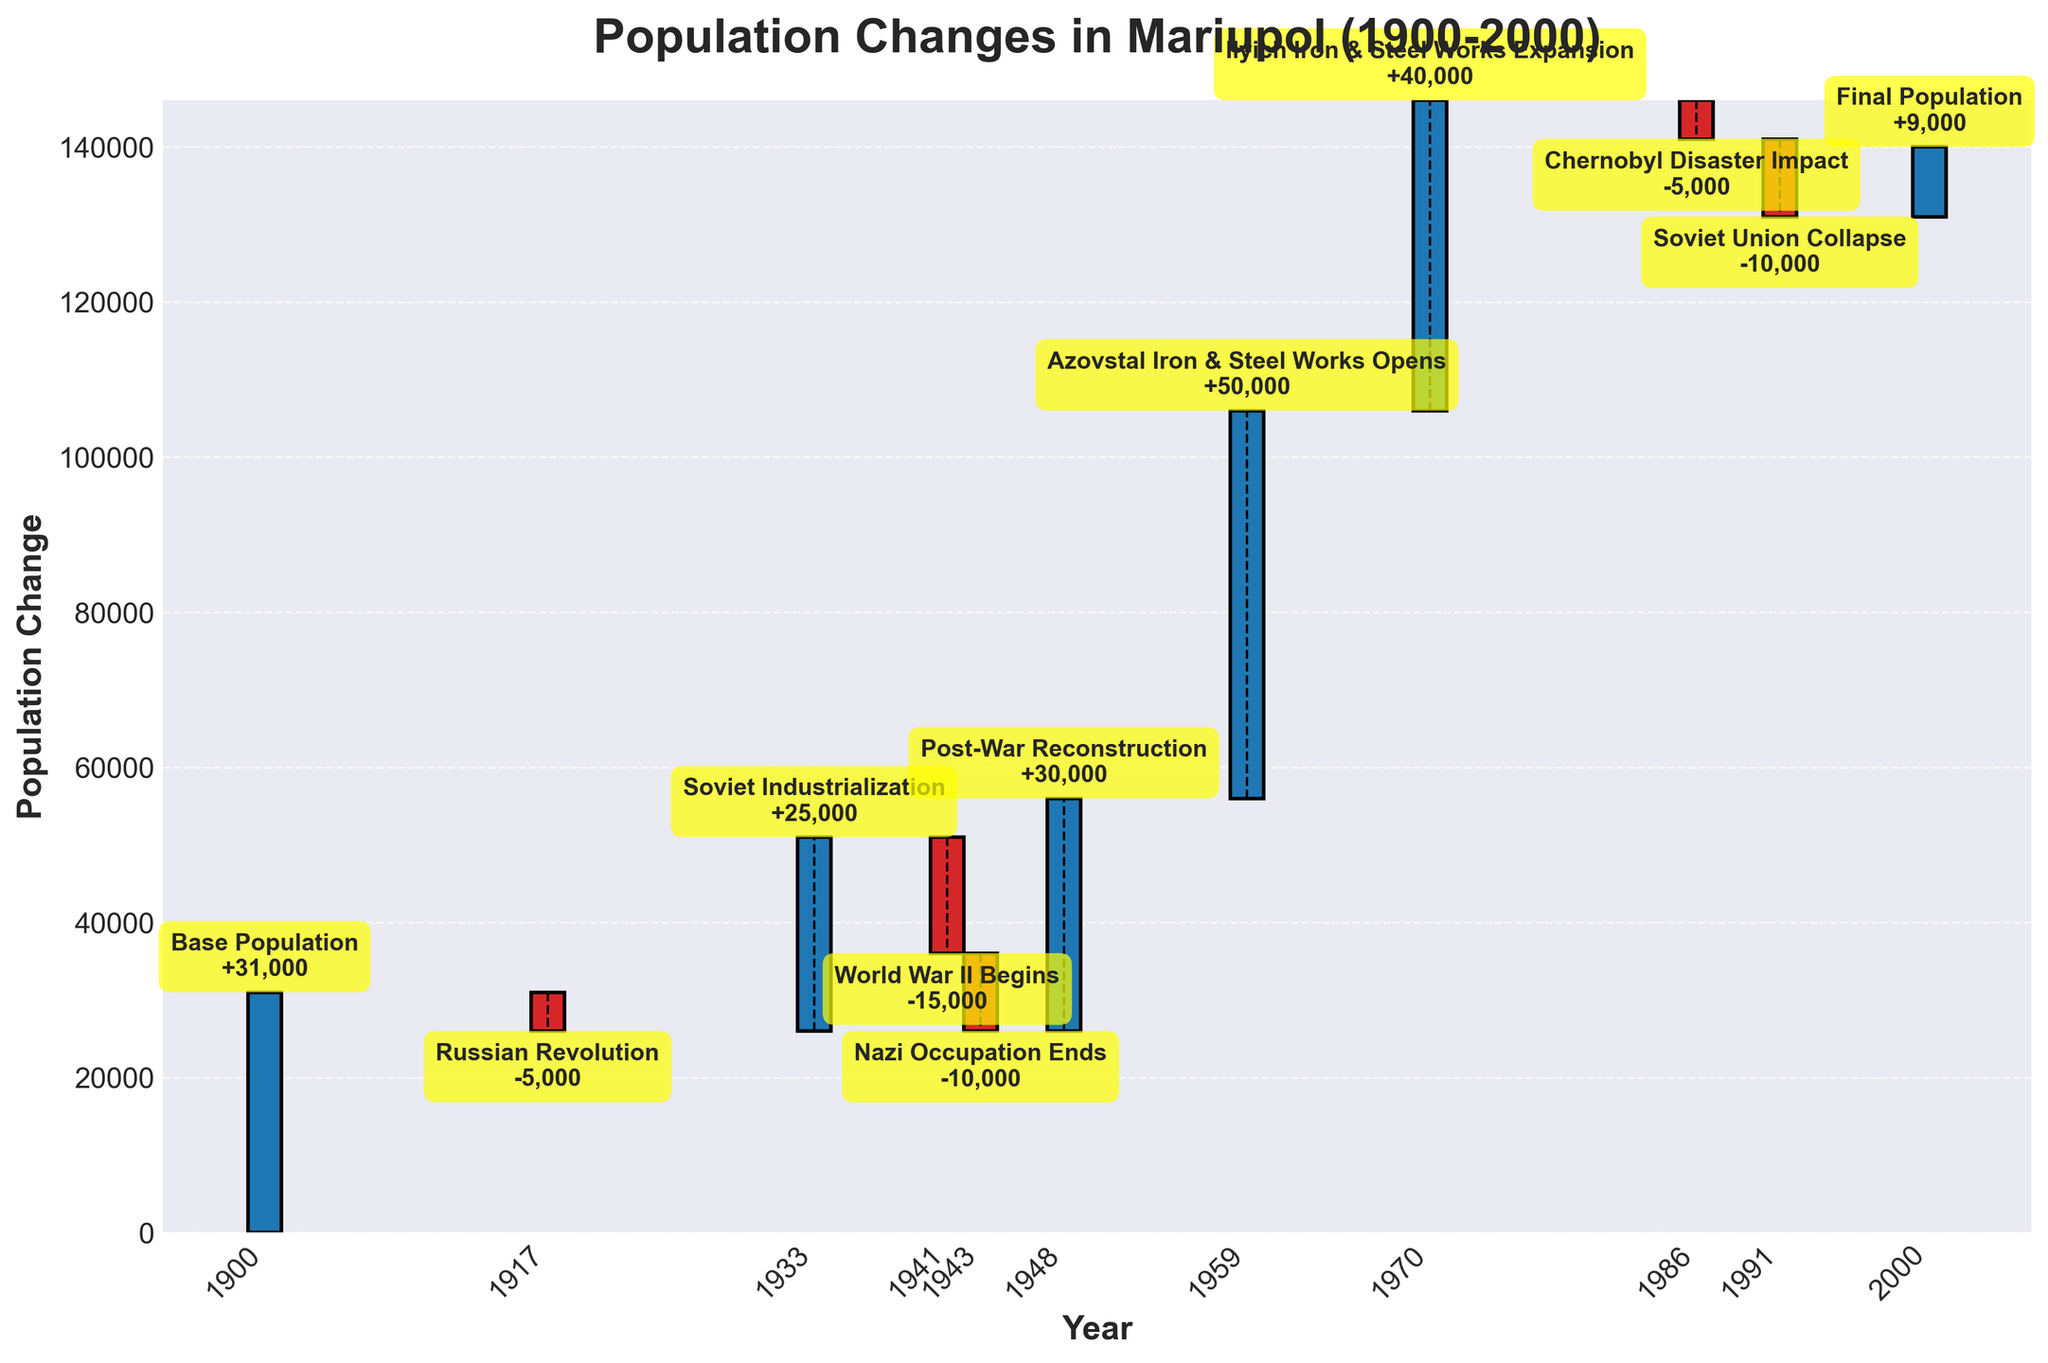What is the title of the chart? The title of the chart is displayed at the top and helps summarize the goal of the visualization.
Answer: Population Changes in Mariupol (1900-2000) How many major population changes are highlighted in the chart? Count the number of bars in the chart, each representing a population change event.
Answer: 11 What event had the largest positive impact on population change? Identify the event with the bar having the highest positive value in the vertical axis. Here, the highest positive change was observed during the opening of the Azovstal Iron & Steel Works with +50,000.
Answer: Azovstal Iron & Steel Works Opens Which event signified the last population change shown in the chart? Find the event corresponding to the last data point (year 2000).
Answer: Final Population What are the total population losses due to negative events in the chart? Sum the negative population changes: -5,000 (Russian Revolution) - 15,000 (World War II Begins) - 10,000 (Nazi Occupation Ends) - 5,000 (Chernobyl Disaster Impact) - 10,000 (Soviet Union Collapse).
Answer: -45,000 Which two events had an equal absolute population change but in opposite directions? Find two events with bars of the same length but different directions: "Russian Revolution" and "Chernobyl Disaster Impact" both have changes of 5,000 but in opposite directions.
Answer: Russian Revolution and Chernobyl Disaster Impact Which event post-1948 had a comparatively lesser impact on population change: the opening of Ilyich Iron & Steel Works or the reconstruction post-war? Compare the bars for "Ilyich Iron & Steel Works Expansion" with a population change of +40,000 and "Post-War Reconstruction" with a population change of +30,000. The latter is lesser.
Answer: Post-War Reconstruction During which decade did Mariupol see the highest population increase according to the chart? Identify the decade using bars of the significant increases: The decade of the 1950s, due to the opening of Azovstal Iron & Steel Works with +50,000 in 1959.
Answer: 1950s 